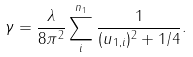Convert formula to latex. <formula><loc_0><loc_0><loc_500><loc_500>\gamma = \frac { \lambda } { 8 \pi ^ { 2 } } \sum _ { i } ^ { n _ { 1 } } \frac { 1 } { ( u _ { 1 , i } ) ^ { 2 } + 1 / 4 } .</formula> 